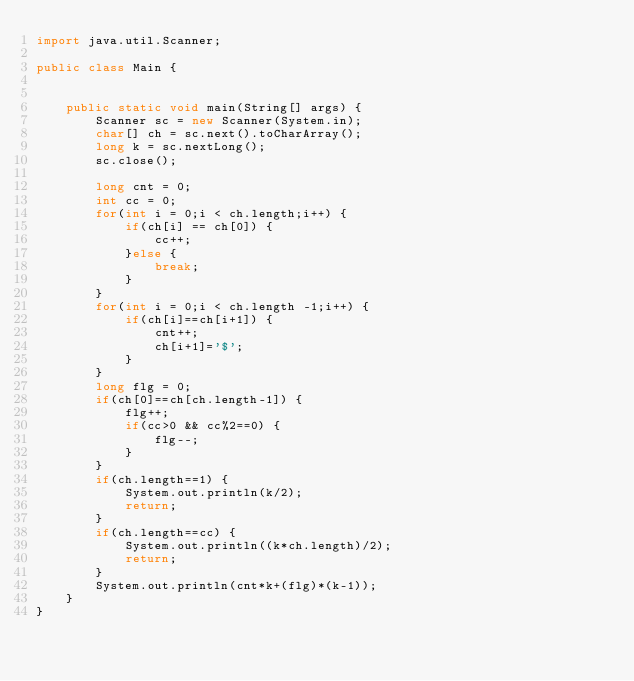<code> <loc_0><loc_0><loc_500><loc_500><_Java_>import java.util.Scanner;

public class Main {


	public static void main(String[] args) {
		Scanner sc = new Scanner(System.in);
		char[] ch = sc.next().toCharArray();
		long k = sc.nextLong();
		sc.close();

		long cnt = 0;
		int cc = 0;
		for(int i = 0;i < ch.length;i++) {
			if(ch[i] == ch[0]) {
				cc++;
			}else {
				break;
			}
		}
		for(int i = 0;i < ch.length -1;i++) {
			if(ch[i]==ch[i+1]) {
				cnt++;
				ch[i+1]='$';
			}
		}
		long flg = 0;
		if(ch[0]==ch[ch.length-1]) {
			flg++;
			if(cc>0 && cc%2==0) {
				flg--;
			}
		}
		if(ch.length==1) {
			System.out.println(k/2);
			return;
		}
		if(ch.length==cc) {
			System.out.println((k*ch.length)/2);
			return;
		}
		System.out.println(cnt*k+(flg)*(k-1));
	}
}
</code> 